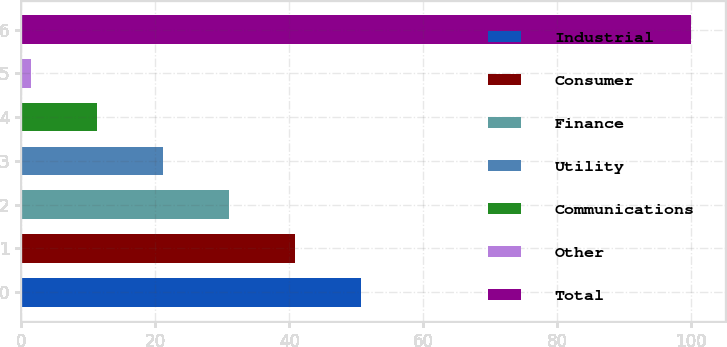Convert chart to OTSL. <chart><loc_0><loc_0><loc_500><loc_500><bar_chart><fcel>Industrial<fcel>Consumer<fcel>Finance<fcel>Utility<fcel>Communications<fcel>Other<fcel>Total<nl><fcel>50.7<fcel>40.84<fcel>30.98<fcel>21.12<fcel>11.26<fcel>1.4<fcel>100<nl></chart> 